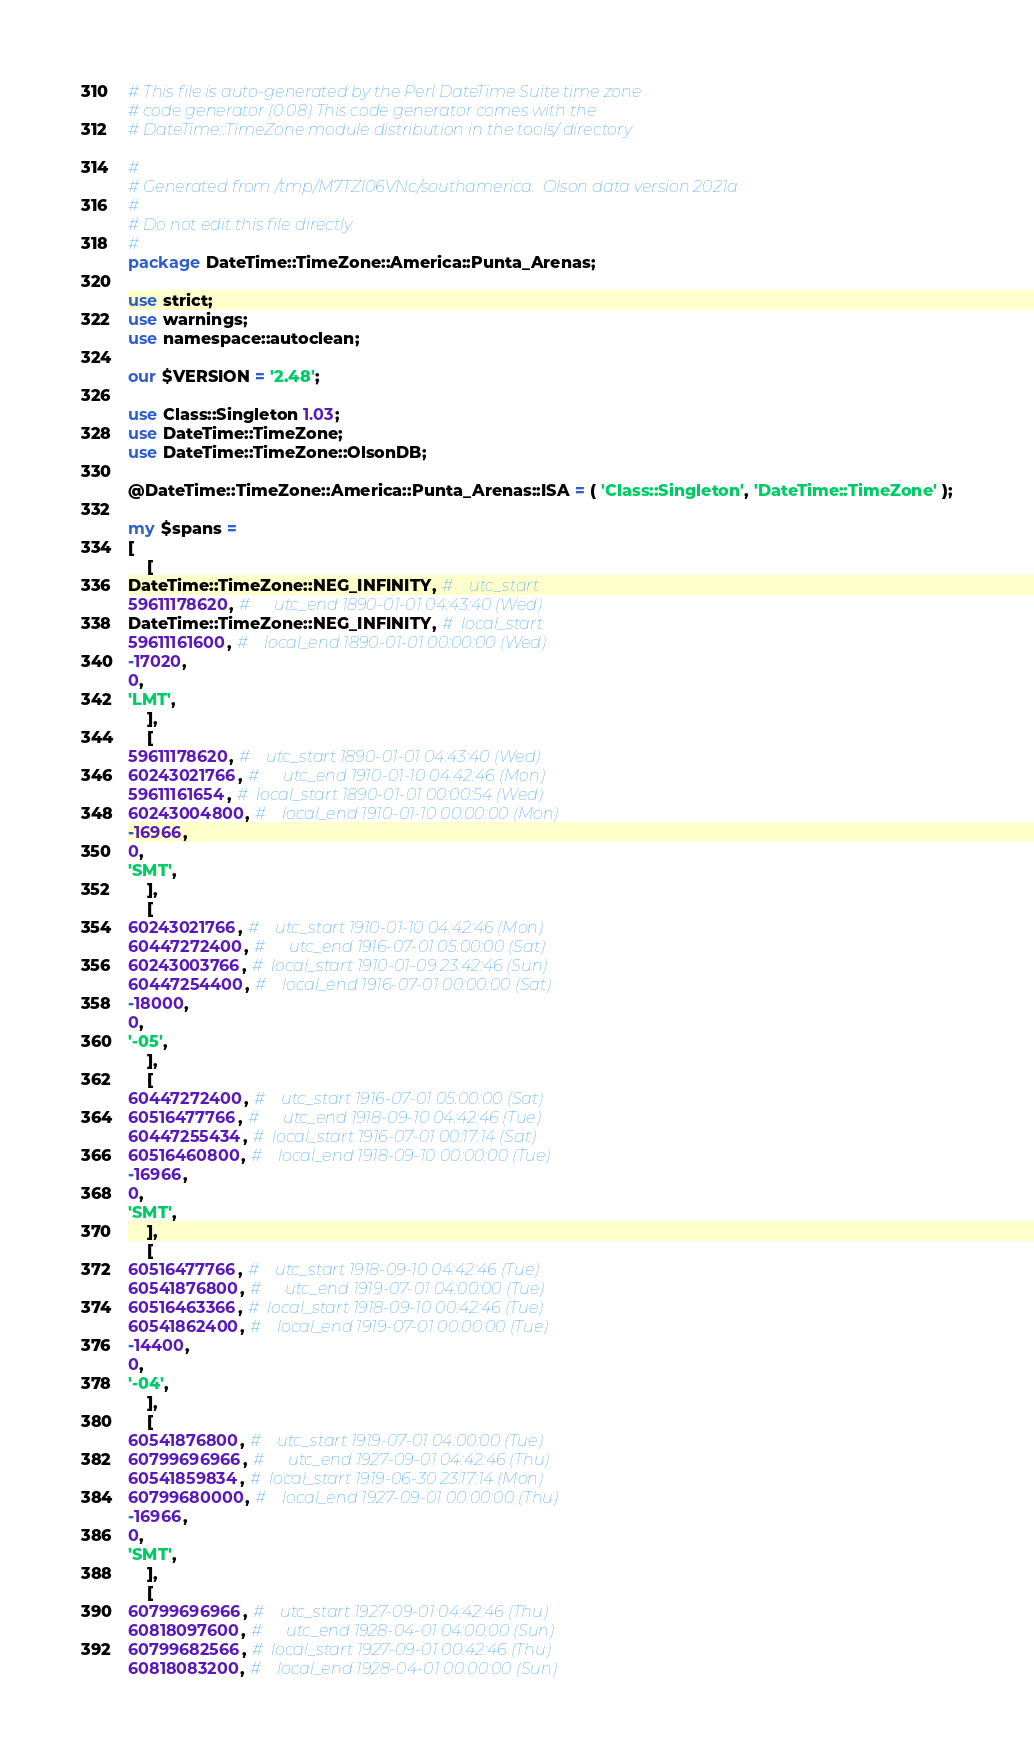Convert code to text. <code><loc_0><loc_0><loc_500><loc_500><_Perl_># This file is auto-generated by the Perl DateTime Suite time zone
# code generator (0.08) This code generator comes with the
# DateTime::TimeZone module distribution in the tools/ directory

#
# Generated from /tmp/M7TZl06VNc/southamerica.  Olson data version 2021a
#
# Do not edit this file directly.
#
package DateTime::TimeZone::America::Punta_Arenas;

use strict;
use warnings;
use namespace::autoclean;

our $VERSION = '2.48';

use Class::Singleton 1.03;
use DateTime::TimeZone;
use DateTime::TimeZone::OlsonDB;

@DateTime::TimeZone::America::Punta_Arenas::ISA = ( 'Class::Singleton', 'DateTime::TimeZone' );

my $spans =
[
    [
DateTime::TimeZone::NEG_INFINITY, #    utc_start
59611178620, #      utc_end 1890-01-01 04:43:40 (Wed)
DateTime::TimeZone::NEG_INFINITY, #  local_start
59611161600, #    local_end 1890-01-01 00:00:00 (Wed)
-17020,
0,
'LMT',
    ],
    [
59611178620, #    utc_start 1890-01-01 04:43:40 (Wed)
60243021766, #      utc_end 1910-01-10 04:42:46 (Mon)
59611161654, #  local_start 1890-01-01 00:00:54 (Wed)
60243004800, #    local_end 1910-01-10 00:00:00 (Mon)
-16966,
0,
'SMT',
    ],
    [
60243021766, #    utc_start 1910-01-10 04:42:46 (Mon)
60447272400, #      utc_end 1916-07-01 05:00:00 (Sat)
60243003766, #  local_start 1910-01-09 23:42:46 (Sun)
60447254400, #    local_end 1916-07-01 00:00:00 (Sat)
-18000,
0,
'-05',
    ],
    [
60447272400, #    utc_start 1916-07-01 05:00:00 (Sat)
60516477766, #      utc_end 1918-09-10 04:42:46 (Tue)
60447255434, #  local_start 1916-07-01 00:17:14 (Sat)
60516460800, #    local_end 1918-09-10 00:00:00 (Tue)
-16966,
0,
'SMT',
    ],
    [
60516477766, #    utc_start 1918-09-10 04:42:46 (Tue)
60541876800, #      utc_end 1919-07-01 04:00:00 (Tue)
60516463366, #  local_start 1918-09-10 00:42:46 (Tue)
60541862400, #    local_end 1919-07-01 00:00:00 (Tue)
-14400,
0,
'-04',
    ],
    [
60541876800, #    utc_start 1919-07-01 04:00:00 (Tue)
60799696966, #      utc_end 1927-09-01 04:42:46 (Thu)
60541859834, #  local_start 1919-06-30 23:17:14 (Mon)
60799680000, #    local_end 1927-09-01 00:00:00 (Thu)
-16966,
0,
'SMT',
    ],
    [
60799696966, #    utc_start 1927-09-01 04:42:46 (Thu)
60818097600, #      utc_end 1928-04-01 04:00:00 (Sun)
60799682566, #  local_start 1927-09-01 00:42:46 (Thu)
60818083200, #    local_end 1928-04-01 00:00:00 (Sun)</code> 